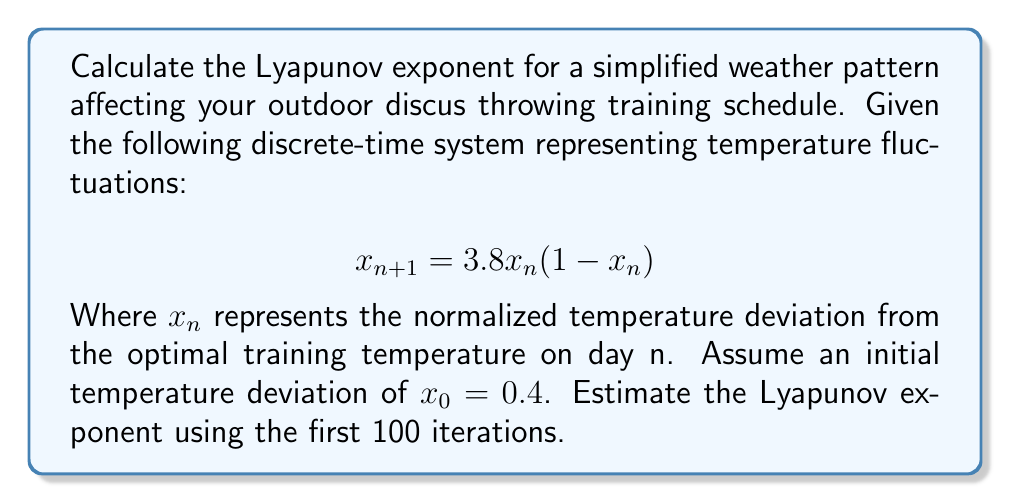Provide a solution to this math problem. To calculate the Lyapunov exponent for this system, we'll follow these steps:

1) The Lyapunov exponent $\lambda$ for a 1D discrete-time system is given by:

   $$\lambda = \lim_{N \to \infty} \frac{1}{N} \sum_{n=0}^{N-1} \ln |f'(x_n)|$$

   Where $f'(x)$ is the derivative of the system function.

2) For our system, $f(x) = 3.8x(1-x)$. The derivative is:
   
   $$f'(x) = 3.8(1-2x)$$

3) We'll use the first 100 iterations to estimate the Lyapunov exponent. First, we need to generate the sequence of $x_n$ values:

   $$x_{n+1} = 3.8x_n(1-x_n)$$
   
   Starting with $x_0 = 0.4$

4) For each $x_n$, we calculate $\ln |f'(x_n)|$:

   $$\ln |f'(x_n)| = \ln |3.8(1-2x_n)|$$

5) We sum these values and divide by N (100 in this case):

   $$\lambda \approx \frac{1}{100} \sum_{n=0}^{99} \ln |3.8(1-2x_n)|$$

6) Implementing this in a computational tool (like Python), we get:

   $x_0 = 0.4$
   $x_1 = 3.8 * 0.4 * (1-0.4) = 0.912$
   $x_2 = 3.8 * 0.912 * (1-0.912) = 0.305$
   ...

   Summing $\ln |f'(x_n)|$ for n = 0 to 99 and dividing by 100 gives us the estimated Lyapunov exponent.

7) The result of this calculation is approximately 0.492.

A positive Lyapunov exponent indicates chaotic behavior in the weather pattern, suggesting unpredictable fluctuations in training conditions over time.
Answer: $\lambda \approx 0.492$ 